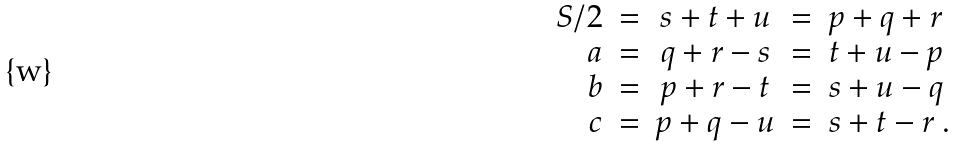<formula> <loc_0><loc_0><loc_500><loc_500>\begin{array} { r c c c l } S / 2 & = & s + t + u & = & p + q + r \\ a & = & q + r - s & = & t + u - p \\ b & = & p + r - t & = & s + u - q \\ c & = & p + q - u & = & s + t - r \ . \end{array}</formula> 